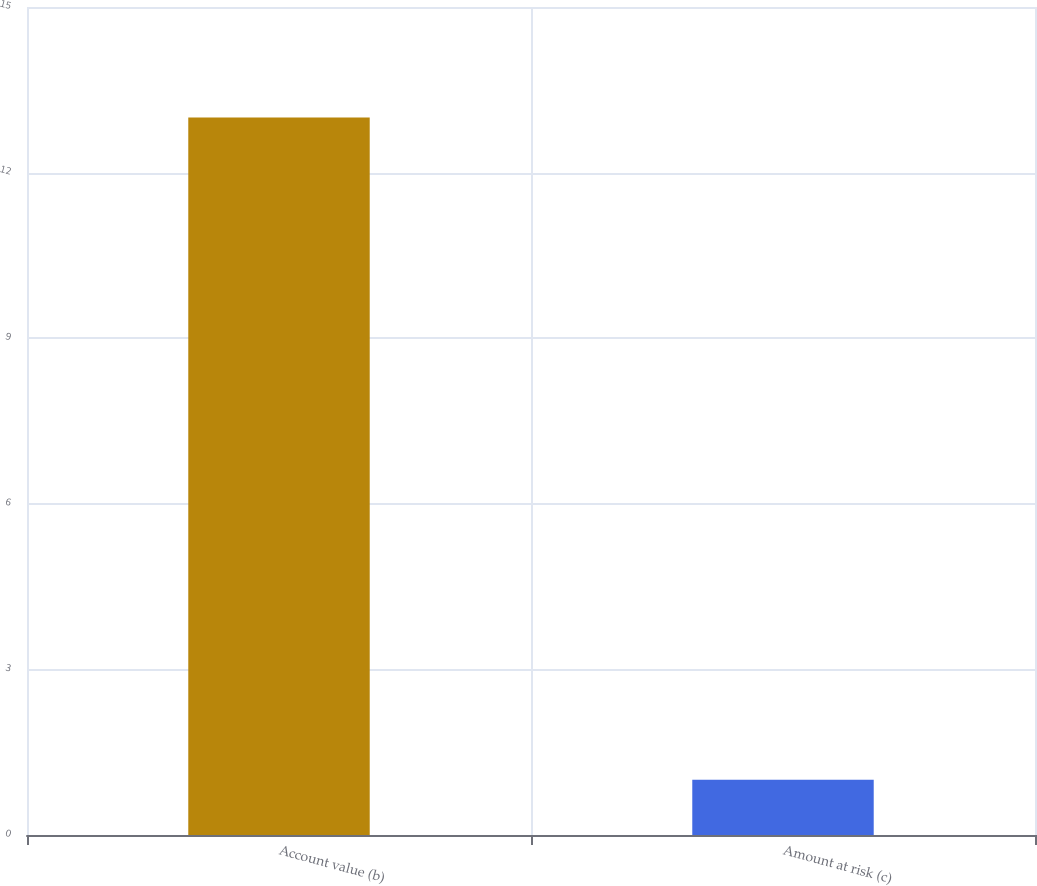Convert chart to OTSL. <chart><loc_0><loc_0><loc_500><loc_500><bar_chart><fcel>Account value (b)<fcel>Amount at risk (c)<nl><fcel>13<fcel>1<nl></chart> 